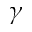<formula> <loc_0><loc_0><loc_500><loc_500>\gamma</formula> 